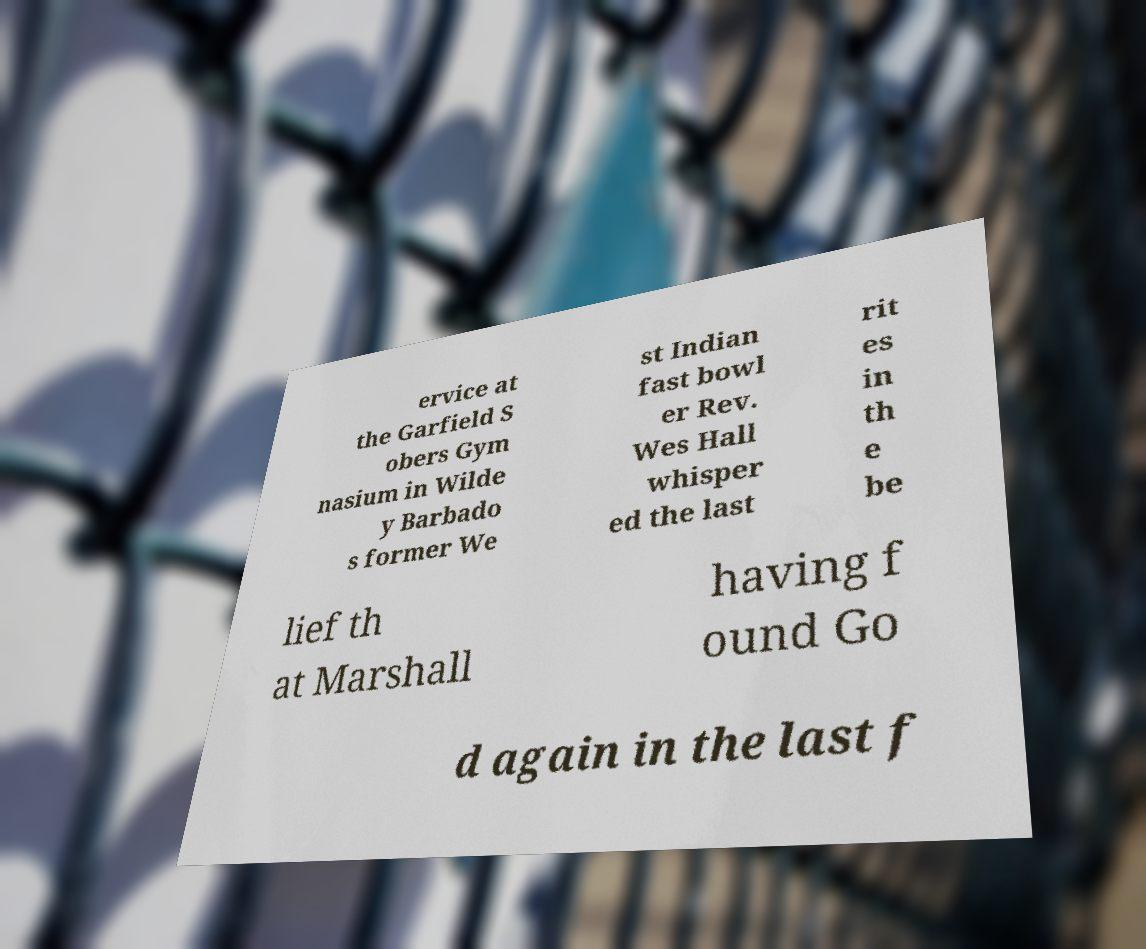Can you read and provide the text displayed in the image?This photo seems to have some interesting text. Can you extract and type it out for me? ervice at the Garfield S obers Gym nasium in Wilde y Barbado s former We st Indian fast bowl er Rev. Wes Hall whisper ed the last rit es in th e be lief th at Marshall having f ound Go d again in the last f 